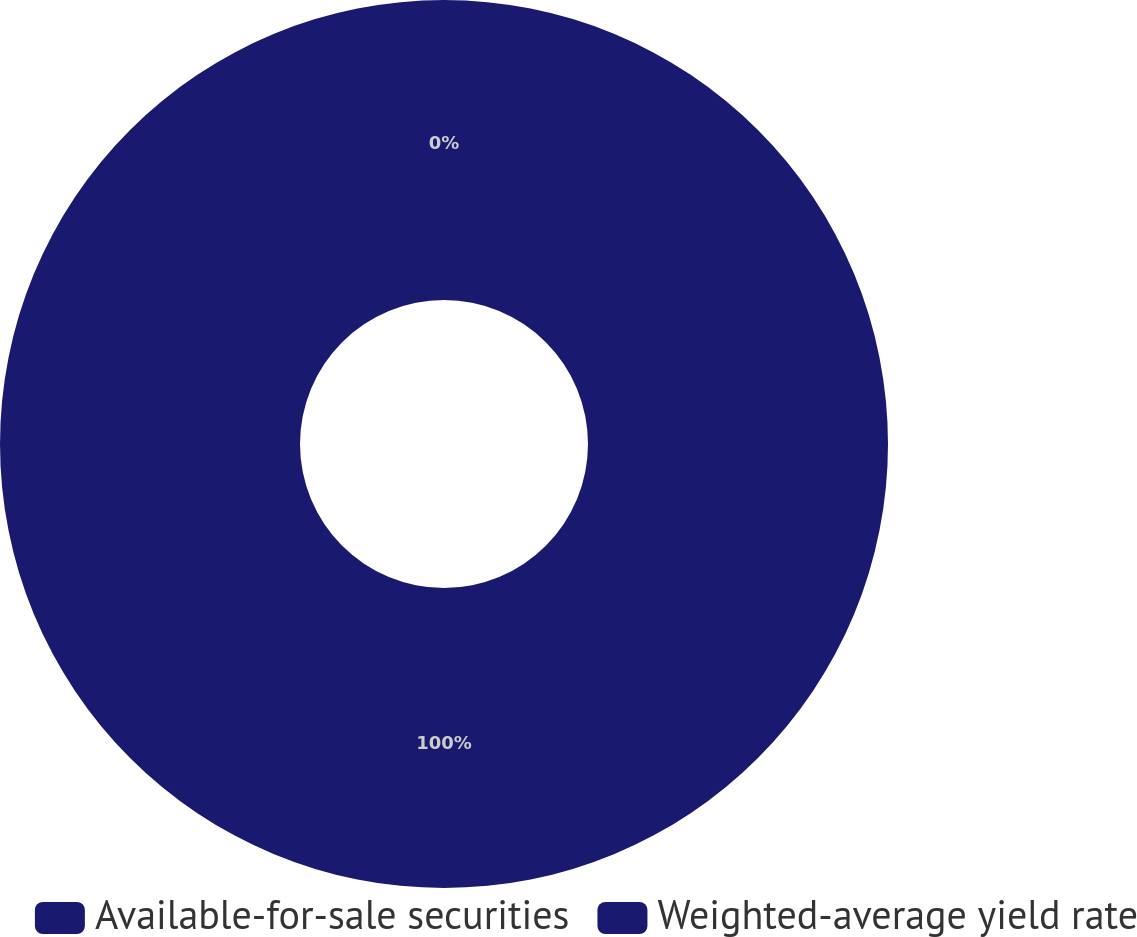Convert chart. <chart><loc_0><loc_0><loc_500><loc_500><pie_chart><fcel>Available-for-sale securities<fcel>Weighted-average yield rate<nl><fcel>100.0%<fcel>0.0%<nl></chart> 